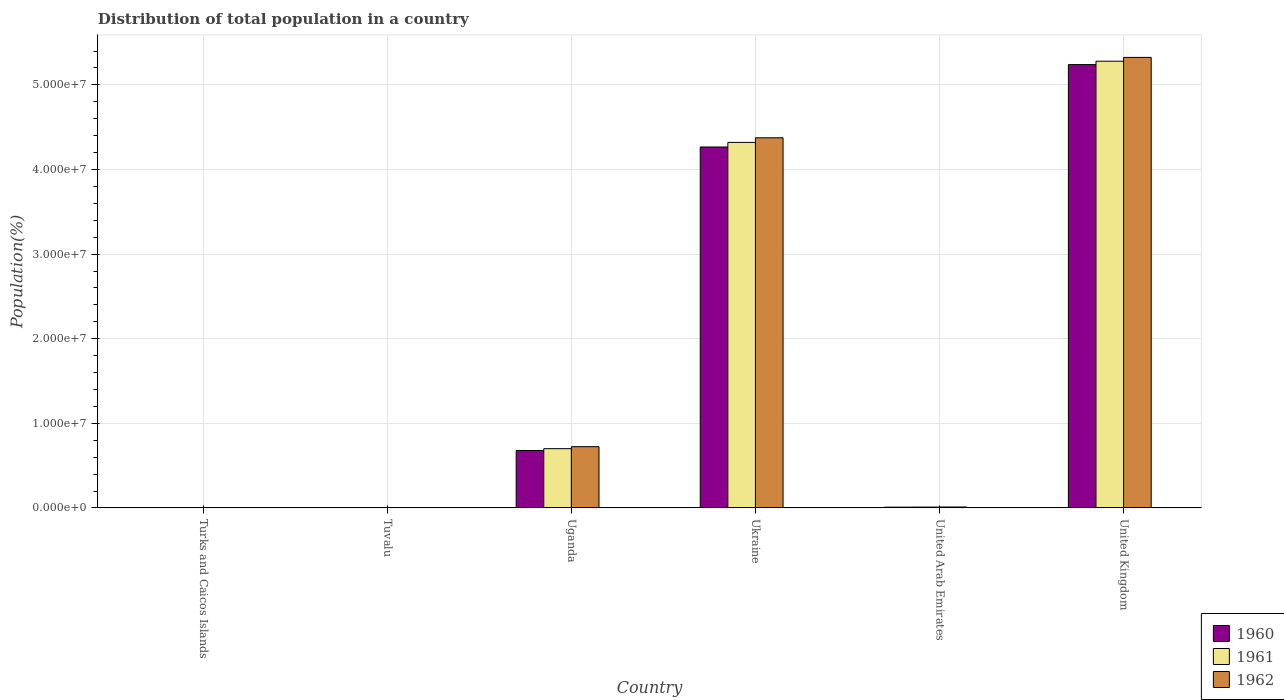How many groups of bars are there?
Provide a succinct answer. 6. How many bars are there on the 5th tick from the right?
Provide a succinct answer. 3. What is the label of the 4th group of bars from the left?
Your response must be concise. Ukraine. What is the population of in 1962 in Uganda?
Ensure brevity in your answer.  7.24e+06. Across all countries, what is the maximum population of in 1960?
Give a very brief answer. 5.24e+07. Across all countries, what is the minimum population of in 1960?
Ensure brevity in your answer.  5724. In which country was the population of in 1962 minimum?
Offer a very short reply. Turks and Caicos Islands. What is the total population of in 1962 in the graph?
Your response must be concise. 1.04e+08. What is the difference between the population of in 1962 in Tuvalu and that in Uganda?
Make the answer very short. -7.23e+06. What is the difference between the population of in 1962 in United Kingdom and the population of in 1961 in United Arab Emirates?
Provide a succinct answer. 5.31e+07. What is the average population of in 1962 per country?
Make the answer very short. 1.74e+07. What is the difference between the population of of/in 1962 and population of of/in 1960 in United Arab Emirates?
Provide a succinct answer. 1.96e+04. In how many countries, is the population of in 1961 greater than 20000000 %?
Provide a short and direct response. 2. What is the ratio of the population of in 1962 in Turks and Caicos Islands to that in United Arab Emirates?
Offer a very short reply. 0.05. Is the population of in 1962 in United Arab Emirates less than that in United Kingdom?
Provide a succinct answer. Yes. What is the difference between the highest and the second highest population of in 1961?
Offer a terse response. 9.60e+06. What is the difference between the highest and the lowest population of in 1962?
Your answer should be very brief. 5.32e+07. In how many countries, is the population of in 1962 greater than the average population of in 1962 taken over all countries?
Keep it short and to the point. 2. Is the sum of the population of in 1961 in Ukraine and United Kingdom greater than the maximum population of in 1962 across all countries?
Make the answer very short. Yes. What does the 2nd bar from the left in Ukraine represents?
Offer a terse response. 1961. How many bars are there?
Give a very brief answer. 18. Are all the bars in the graph horizontal?
Provide a short and direct response. No. What is the difference between two consecutive major ticks on the Y-axis?
Keep it short and to the point. 1.00e+07. Does the graph contain any zero values?
Give a very brief answer. No. Where does the legend appear in the graph?
Make the answer very short. Bottom right. What is the title of the graph?
Give a very brief answer. Distribution of total population in a country. What is the label or title of the X-axis?
Make the answer very short. Country. What is the label or title of the Y-axis?
Give a very brief answer. Population(%). What is the Population(%) in 1960 in Turks and Caicos Islands?
Give a very brief answer. 5724. What is the Population(%) of 1961 in Turks and Caicos Islands?
Keep it short and to the point. 5760. What is the Population(%) in 1962 in Turks and Caicos Islands?
Your answer should be very brief. 5762. What is the Population(%) in 1960 in Tuvalu?
Provide a succinct answer. 6104. What is the Population(%) of 1961 in Tuvalu?
Ensure brevity in your answer.  6242. What is the Population(%) of 1962 in Tuvalu?
Offer a very short reply. 6391. What is the Population(%) in 1960 in Uganda?
Offer a very short reply. 6.79e+06. What is the Population(%) of 1961 in Uganda?
Offer a very short reply. 7.01e+06. What is the Population(%) of 1962 in Uganda?
Offer a terse response. 7.24e+06. What is the Population(%) in 1960 in Ukraine?
Your answer should be very brief. 4.27e+07. What is the Population(%) in 1961 in Ukraine?
Provide a succinct answer. 4.32e+07. What is the Population(%) in 1962 in Ukraine?
Provide a succinct answer. 4.37e+07. What is the Population(%) in 1960 in United Arab Emirates?
Make the answer very short. 9.26e+04. What is the Population(%) of 1961 in United Arab Emirates?
Ensure brevity in your answer.  1.01e+05. What is the Population(%) of 1962 in United Arab Emirates?
Keep it short and to the point. 1.12e+05. What is the Population(%) of 1960 in United Kingdom?
Offer a terse response. 5.24e+07. What is the Population(%) in 1961 in United Kingdom?
Ensure brevity in your answer.  5.28e+07. What is the Population(%) of 1962 in United Kingdom?
Your answer should be very brief. 5.32e+07. Across all countries, what is the maximum Population(%) of 1960?
Offer a terse response. 5.24e+07. Across all countries, what is the maximum Population(%) in 1961?
Offer a very short reply. 5.28e+07. Across all countries, what is the maximum Population(%) of 1962?
Ensure brevity in your answer.  5.32e+07. Across all countries, what is the minimum Population(%) of 1960?
Ensure brevity in your answer.  5724. Across all countries, what is the minimum Population(%) of 1961?
Offer a terse response. 5760. Across all countries, what is the minimum Population(%) of 1962?
Offer a very short reply. 5762. What is the total Population(%) of 1960 in the graph?
Offer a very short reply. 1.02e+08. What is the total Population(%) of 1961 in the graph?
Make the answer very short. 1.03e+08. What is the total Population(%) of 1962 in the graph?
Keep it short and to the point. 1.04e+08. What is the difference between the Population(%) in 1960 in Turks and Caicos Islands and that in Tuvalu?
Your answer should be compact. -380. What is the difference between the Population(%) in 1961 in Turks and Caicos Islands and that in Tuvalu?
Make the answer very short. -482. What is the difference between the Population(%) in 1962 in Turks and Caicos Islands and that in Tuvalu?
Provide a short and direct response. -629. What is the difference between the Population(%) of 1960 in Turks and Caicos Islands and that in Uganda?
Ensure brevity in your answer.  -6.78e+06. What is the difference between the Population(%) of 1961 in Turks and Caicos Islands and that in Uganda?
Offer a very short reply. -7.00e+06. What is the difference between the Population(%) in 1962 in Turks and Caicos Islands and that in Uganda?
Give a very brief answer. -7.23e+06. What is the difference between the Population(%) in 1960 in Turks and Caicos Islands and that in Ukraine?
Make the answer very short. -4.27e+07. What is the difference between the Population(%) of 1961 in Turks and Caicos Islands and that in Ukraine?
Ensure brevity in your answer.  -4.32e+07. What is the difference between the Population(%) of 1962 in Turks and Caicos Islands and that in Ukraine?
Your answer should be compact. -4.37e+07. What is the difference between the Population(%) in 1960 in Turks and Caicos Islands and that in United Arab Emirates?
Ensure brevity in your answer.  -8.69e+04. What is the difference between the Population(%) of 1961 in Turks and Caicos Islands and that in United Arab Emirates?
Ensure brevity in your answer.  -9.52e+04. What is the difference between the Population(%) in 1962 in Turks and Caicos Islands and that in United Arab Emirates?
Offer a terse response. -1.06e+05. What is the difference between the Population(%) in 1960 in Turks and Caicos Islands and that in United Kingdom?
Your answer should be very brief. -5.24e+07. What is the difference between the Population(%) of 1961 in Turks and Caicos Islands and that in United Kingdom?
Make the answer very short. -5.28e+07. What is the difference between the Population(%) in 1962 in Turks and Caicos Islands and that in United Kingdom?
Ensure brevity in your answer.  -5.32e+07. What is the difference between the Population(%) of 1960 in Tuvalu and that in Uganda?
Offer a terse response. -6.78e+06. What is the difference between the Population(%) in 1961 in Tuvalu and that in Uganda?
Ensure brevity in your answer.  -7.00e+06. What is the difference between the Population(%) in 1962 in Tuvalu and that in Uganda?
Give a very brief answer. -7.23e+06. What is the difference between the Population(%) in 1960 in Tuvalu and that in Ukraine?
Your response must be concise. -4.27e+07. What is the difference between the Population(%) in 1961 in Tuvalu and that in Ukraine?
Provide a short and direct response. -4.32e+07. What is the difference between the Population(%) in 1962 in Tuvalu and that in Ukraine?
Offer a terse response. -4.37e+07. What is the difference between the Population(%) of 1960 in Tuvalu and that in United Arab Emirates?
Your answer should be very brief. -8.65e+04. What is the difference between the Population(%) in 1961 in Tuvalu and that in United Arab Emirates?
Provide a short and direct response. -9.47e+04. What is the difference between the Population(%) of 1962 in Tuvalu and that in United Arab Emirates?
Your answer should be very brief. -1.06e+05. What is the difference between the Population(%) in 1960 in Tuvalu and that in United Kingdom?
Ensure brevity in your answer.  -5.24e+07. What is the difference between the Population(%) in 1961 in Tuvalu and that in United Kingdom?
Provide a short and direct response. -5.28e+07. What is the difference between the Population(%) of 1962 in Tuvalu and that in United Kingdom?
Your response must be concise. -5.32e+07. What is the difference between the Population(%) of 1960 in Uganda and that in Ukraine?
Provide a short and direct response. -3.59e+07. What is the difference between the Population(%) of 1961 in Uganda and that in Ukraine?
Your response must be concise. -3.62e+07. What is the difference between the Population(%) in 1962 in Uganda and that in Ukraine?
Ensure brevity in your answer.  -3.65e+07. What is the difference between the Population(%) in 1960 in Uganda and that in United Arab Emirates?
Give a very brief answer. 6.70e+06. What is the difference between the Population(%) in 1961 in Uganda and that in United Arab Emirates?
Give a very brief answer. 6.91e+06. What is the difference between the Population(%) of 1962 in Uganda and that in United Arab Emirates?
Your answer should be very brief. 7.13e+06. What is the difference between the Population(%) in 1960 in Uganda and that in United Kingdom?
Your response must be concise. -4.56e+07. What is the difference between the Population(%) of 1961 in Uganda and that in United Kingdom?
Make the answer very short. -4.58e+07. What is the difference between the Population(%) in 1962 in Uganda and that in United Kingdom?
Your answer should be compact. -4.60e+07. What is the difference between the Population(%) in 1960 in Ukraine and that in United Arab Emirates?
Offer a very short reply. 4.26e+07. What is the difference between the Population(%) of 1961 in Ukraine and that in United Arab Emirates?
Offer a terse response. 4.31e+07. What is the difference between the Population(%) in 1962 in Ukraine and that in United Arab Emirates?
Offer a terse response. 4.36e+07. What is the difference between the Population(%) of 1960 in Ukraine and that in United Kingdom?
Keep it short and to the point. -9.74e+06. What is the difference between the Population(%) of 1961 in Ukraine and that in United Kingdom?
Make the answer very short. -9.60e+06. What is the difference between the Population(%) in 1962 in Ukraine and that in United Kingdom?
Offer a very short reply. -9.50e+06. What is the difference between the Population(%) in 1960 in United Arab Emirates and that in United Kingdom?
Your answer should be compact. -5.23e+07. What is the difference between the Population(%) of 1961 in United Arab Emirates and that in United Kingdom?
Your answer should be compact. -5.27e+07. What is the difference between the Population(%) in 1962 in United Arab Emirates and that in United Kingdom?
Make the answer very short. -5.31e+07. What is the difference between the Population(%) in 1960 in Turks and Caicos Islands and the Population(%) in 1961 in Tuvalu?
Make the answer very short. -518. What is the difference between the Population(%) of 1960 in Turks and Caicos Islands and the Population(%) of 1962 in Tuvalu?
Offer a terse response. -667. What is the difference between the Population(%) in 1961 in Turks and Caicos Islands and the Population(%) in 1962 in Tuvalu?
Provide a short and direct response. -631. What is the difference between the Population(%) of 1960 in Turks and Caicos Islands and the Population(%) of 1961 in Uganda?
Your answer should be compact. -7.00e+06. What is the difference between the Population(%) in 1960 in Turks and Caicos Islands and the Population(%) in 1962 in Uganda?
Provide a succinct answer. -7.23e+06. What is the difference between the Population(%) in 1961 in Turks and Caicos Islands and the Population(%) in 1962 in Uganda?
Provide a succinct answer. -7.23e+06. What is the difference between the Population(%) in 1960 in Turks and Caicos Islands and the Population(%) in 1961 in Ukraine?
Ensure brevity in your answer.  -4.32e+07. What is the difference between the Population(%) in 1960 in Turks and Caicos Islands and the Population(%) in 1962 in Ukraine?
Provide a succinct answer. -4.37e+07. What is the difference between the Population(%) of 1961 in Turks and Caicos Islands and the Population(%) of 1962 in Ukraine?
Keep it short and to the point. -4.37e+07. What is the difference between the Population(%) of 1960 in Turks and Caicos Islands and the Population(%) of 1961 in United Arab Emirates?
Keep it short and to the point. -9.53e+04. What is the difference between the Population(%) of 1960 in Turks and Caicos Islands and the Population(%) of 1962 in United Arab Emirates?
Provide a succinct answer. -1.07e+05. What is the difference between the Population(%) in 1961 in Turks and Caicos Islands and the Population(%) in 1962 in United Arab Emirates?
Offer a very short reply. -1.06e+05. What is the difference between the Population(%) in 1960 in Turks and Caicos Islands and the Population(%) in 1961 in United Kingdom?
Ensure brevity in your answer.  -5.28e+07. What is the difference between the Population(%) in 1960 in Turks and Caicos Islands and the Population(%) in 1962 in United Kingdom?
Offer a terse response. -5.32e+07. What is the difference between the Population(%) in 1961 in Turks and Caicos Islands and the Population(%) in 1962 in United Kingdom?
Your response must be concise. -5.32e+07. What is the difference between the Population(%) in 1960 in Tuvalu and the Population(%) in 1961 in Uganda?
Your response must be concise. -7.00e+06. What is the difference between the Population(%) in 1960 in Tuvalu and the Population(%) in 1962 in Uganda?
Make the answer very short. -7.23e+06. What is the difference between the Population(%) of 1961 in Tuvalu and the Population(%) of 1962 in Uganda?
Provide a succinct answer. -7.23e+06. What is the difference between the Population(%) of 1960 in Tuvalu and the Population(%) of 1961 in Ukraine?
Give a very brief answer. -4.32e+07. What is the difference between the Population(%) in 1960 in Tuvalu and the Population(%) in 1962 in Ukraine?
Give a very brief answer. -4.37e+07. What is the difference between the Population(%) of 1961 in Tuvalu and the Population(%) of 1962 in Ukraine?
Provide a succinct answer. -4.37e+07. What is the difference between the Population(%) in 1960 in Tuvalu and the Population(%) in 1961 in United Arab Emirates?
Keep it short and to the point. -9.49e+04. What is the difference between the Population(%) in 1960 in Tuvalu and the Population(%) in 1962 in United Arab Emirates?
Your response must be concise. -1.06e+05. What is the difference between the Population(%) of 1961 in Tuvalu and the Population(%) of 1962 in United Arab Emirates?
Ensure brevity in your answer.  -1.06e+05. What is the difference between the Population(%) of 1960 in Tuvalu and the Population(%) of 1961 in United Kingdom?
Give a very brief answer. -5.28e+07. What is the difference between the Population(%) of 1960 in Tuvalu and the Population(%) of 1962 in United Kingdom?
Your response must be concise. -5.32e+07. What is the difference between the Population(%) of 1961 in Tuvalu and the Population(%) of 1962 in United Kingdom?
Ensure brevity in your answer.  -5.32e+07. What is the difference between the Population(%) in 1960 in Uganda and the Population(%) in 1961 in Ukraine?
Your answer should be compact. -3.64e+07. What is the difference between the Population(%) in 1960 in Uganda and the Population(%) in 1962 in Ukraine?
Provide a succinct answer. -3.70e+07. What is the difference between the Population(%) in 1961 in Uganda and the Population(%) in 1962 in Ukraine?
Give a very brief answer. -3.67e+07. What is the difference between the Population(%) in 1960 in Uganda and the Population(%) in 1961 in United Arab Emirates?
Keep it short and to the point. 6.69e+06. What is the difference between the Population(%) of 1960 in Uganda and the Population(%) of 1962 in United Arab Emirates?
Your answer should be very brief. 6.68e+06. What is the difference between the Population(%) of 1961 in Uganda and the Population(%) of 1962 in United Arab Emirates?
Offer a very short reply. 6.89e+06. What is the difference between the Population(%) in 1960 in Uganda and the Population(%) in 1961 in United Kingdom?
Keep it short and to the point. -4.60e+07. What is the difference between the Population(%) in 1960 in Uganda and the Population(%) in 1962 in United Kingdom?
Provide a succinct answer. -4.65e+07. What is the difference between the Population(%) of 1961 in Uganda and the Population(%) of 1962 in United Kingdom?
Your response must be concise. -4.62e+07. What is the difference between the Population(%) in 1960 in Ukraine and the Population(%) in 1961 in United Arab Emirates?
Your response must be concise. 4.26e+07. What is the difference between the Population(%) in 1960 in Ukraine and the Population(%) in 1962 in United Arab Emirates?
Give a very brief answer. 4.25e+07. What is the difference between the Population(%) of 1961 in Ukraine and the Population(%) of 1962 in United Arab Emirates?
Keep it short and to the point. 4.31e+07. What is the difference between the Population(%) in 1960 in Ukraine and the Population(%) in 1961 in United Kingdom?
Make the answer very short. -1.01e+07. What is the difference between the Population(%) in 1960 in Ukraine and the Population(%) in 1962 in United Kingdom?
Your answer should be very brief. -1.06e+07. What is the difference between the Population(%) in 1961 in Ukraine and the Population(%) in 1962 in United Kingdom?
Provide a succinct answer. -1.00e+07. What is the difference between the Population(%) of 1960 in United Arab Emirates and the Population(%) of 1961 in United Kingdom?
Your answer should be compact. -5.27e+07. What is the difference between the Population(%) in 1960 in United Arab Emirates and the Population(%) in 1962 in United Kingdom?
Your answer should be compact. -5.32e+07. What is the difference between the Population(%) in 1961 in United Arab Emirates and the Population(%) in 1962 in United Kingdom?
Provide a succinct answer. -5.31e+07. What is the average Population(%) of 1960 per country?
Provide a succinct answer. 1.70e+07. What is the average Population(%) of 1961 per country?
Provide a succinct answer. 1.72e+07. What is the average Population(%) of 1962 per country?
Provide a short and direct response. 1.74e+07. What is the difference between the Population(%) in 1960 and Population(%) in 1961 in Turks and Caicos Islands?
Your answer should be very brief. -36. What is the difference between the Population(%) in 1960 and Population(%) in 1962 in Turks and Caicos Islands?
Offer a terse response. -38. What is the difference between the Population(%) in 1961 and Population(%) in 1962 in Turks and Caicos Islands?
Offer a terse response. -2. What is the difference between the Population(%) of 1960 and Population(%) of 1961 in Tuvalu?
Make the answer very short. -138. What is the difference between the Population(%) of 1960 and Population(%) of 1962 in Tuvalu?
Give a very brief answer. -287. What is the difference between the Population(%) in 1961 and Population(%) in 1962 in Tuvalu?
Your answer should be very brief. -149. What is the difference between the Population(%) in 1960 and Population(%) in 1961 in Uganda?
Provide a succinct answer. -2.18e+05. What is the difference between the Population(%) in 1960 and Population(%) in 1962 in Uganda?
Your answer should be compact. -4.52e+05. What is the difference between the Population(%) of 1961 and Population(%) of 1962 in Uganda?
Make the answer very short. -2.34e+05. What is the difference between the Population(%) of 1960 and Population(%) of 1961 in Ukraine?
Your answer should be compact. -5.41e+05. What is the difference between the Population(%) in 1960 and Population(%) in 1962 in Ukraine?
Offer a terse response. -1.09e+06. What is the difference between the Population(%) in 1961 and Population(%) in 1962 in Ukraine?
Offer a terse response. -5.46e+05. What is the difference between the Population(%) of 1960 and Population(%) of 1961 in United Arab Emirates?
Ensure brevity in your answer.  -8373. What is the difference between the Population(%) in 1960 and Population(%) in 1962 in United Arab Emirates?
Make the answer very short. -1.96e+04. What is the difference between the Population(%) of 1961 and Population(%) of 1962 in United Arab Emirates?
Provide a succinct answer. -1.13e+04. What is the difference between the Population(%) of 1960 and Population(%) of 1961 in United Kingdom?
Your response must be concise. -4.00e+05. What is the difference between the Population(%) in 1960 and Population(%) in 1962 in United Kingdom?
Provide a short and direct response. -8.50e+05. What is the difference between the Population(%) of 1961 and Population(%) of 1962 in United Kingdom?
Ensure brevity in your answer.  -4.50e+05. What is the ratio of the Population(%) of 1960 in Turks and Caicos Islands to that in Tuvalu?
Your answer should be very brief. 0.94. What is the ratio of the Population(%) in 1961 in Turks and Caicos Islands to that in Tuvalu?
Offer a terse response. 0.92. What is the ratio of the Population(%) of 1962 in Turks and Caicos Islands to that in Tuvalu?
Ensure brevity in your answer.  0.9. What is the ratio of the Population(%) of 1960 in Turks and Caicos Islands to that in Uganda?
Ensure brevity in your answer.  0. What is the ratio of the Population(%) of 1961 in Turks and Caicos Islands to that in Uganda?
Make the answer very short. 0. What is the ratio of the Population(%) of 1962 in Turks and Caicos Islands to that in Uganda?
Your answer should be very brief. 0. What is the ratio of the Population(%) in 1960 in Turks and Caicos Islands to that in Ukraine?
Ensure brevity in your answer.  0. What is the ratio of the Population(%) of 1961 in Turks and Caicos Islands to that in Ukraine?
Your answer should be very brief. 0. What is the ratio of the Population(%) in 1960 in Turks and Caicos Islands to that in United Arab Emirates?
Your response must be concise. 0.06. What is the ratio of the Population(%) of 1961 in Turks and Caicos Islands to that in United Arab Emirates?
Make the answer very short. 0.06. What is the ratio of the Population(%) in 1962 in Turks and Caicos Islands to that in United Arab Emirates?
Keep it short and to the point. 0.05. What is the ratio of the Population(%) of 1961 in Turks and Caicos Islands to that in United Kingdom?
Keep it short and to the point. 0. What is the ratio of the Population(%) of 1962 in Turks and Caicos Islands to that in United Kingdom?
Provide a succinct answer. 0. What is the ratio of the Population(%) in 1960 in Tuvalu to that in Uganda?
Make the answer very short. 0. What is the ratio of the Population(%) in 1961 in Tuvalu to that in Uganda?
Ensure brevity in your answer.  0. What is the ratio of the Population(%) in 1962 in Tuvalu to that in Uganda?
Offer a terse response. 0. What is the ratio of the Population(%) in 1960 in Tuvalu to that in United Arab Emirates?
Your answer should be compact. 0.07. What is the ratio of the Population(%) of 1961 in Tuvalu to that in United Arab Emirates?
Provide a short and direct response. 0.06. What is the ratio of the Population(%) of 1962 in Tuvalu to that in United Arab Emirates?
Your response must be concise. 0.06. What is the ratio of the Population(%) of 1961 in Tuvalu to that in United Kingdom?
Give a very brief answer. 0. What is the ratio of the Population(%) of 1960 in Uganda to that in Ukraine?
Give a very brief answer. 0.16. What is the ratio of the Population(%) in 1961 in Uganda to that in Ukraine?
Offer a very short reply. 0.16. What is the ratio of the Population(%) of 1962 in Uganda to that in Ukraine?
Offer a terse response. 0.17. What is the ratio of the Population(%) in 1960 in Uganda to that in United Arab Emirates?
Provide a short and direct response. 73.3. What is the ratio of the Population(%) in 1961 in Uganda to that in United Arab Emirates?
Offer a terse response. 69.38. What is the ratio of the Population(%) in 1962 in Uganda to that in United Arab Emirates?
Ensure brevity in your answer.  64.51. What is the ratio of the Population(%) in 1960 in Uganda to that in United Kingdom?
Provide a succinct answer. 0.13. What is the ratio of the Population(%) of 1961 in Uganda to that in United Kingdom?
Your answer should be compact. 0.13. What is the ratio of the Population(%) in 1962 in Uganda to that in United Kingdom?
Your answer should be very brief. 0.14. What is the ratio of the Population(%) in 1960 in Ukraine to that in United Arab Emirates?
Your answer should be compact. 460.65. What is the ratio of the Population(%) in 1961 in Ukraine to that in United Arab Emirates?
Provide a short and direct response. 427.82. What is the ratio of the Population(%) in 1962 in Ukraine to that in United Arab Emirates?
Ensure brevity in your answer.  389.79. What is the ratio of the Population(%) in 1960 in Ukraine to that in United Kingdom?
Ensure brevity in your answer.  0.81. What is the ratio of the Population(%) of 1961 in Ukraine to that in United Kingdom?
Ensure brevity in your answer.  0.82. What is the ratio of the Population(%) of 1962 in Ukraine to that in United Kingdom?
Your answer should be compact. 0.82. What is the ratio of the Population(%) of 1960 in United Arab Emirates to that in United Kingdom?
Ensure brevity in your answer.  0. What is the ratio of the Population(%) of 1961 in United Arab Emirates to that in United Kingdom?
Offer a terse response. 0. What is the ratio of the Population(%) in 1962 in United Arab Emirates to that in United Kingdom?
Give a very brief answer. 0. What is the difference between the highest and the second highest Population(%) of 1960?
Ensure brevity in your answer.  9.74e+06. What is the difference between the highest and the second highest Population(%) in 1961?
Provide a short and direct response. 9.60e+06. What is the difference between the highest and the second highest Population(%) in 1962?
Offer a terse response. 9.50e+06. What is the difference between the highest and the lowest Population(%) in 1960?
Your answer should be compact. 5.24e+07. What is the difference between the highest and the lowest Population(%) of 1961?
Provide a short and direct response. 5.28e+07. What is the difference between the highest and the lowest Population(%) of 1962?
Your answer should be compact. 5.32e+07. 